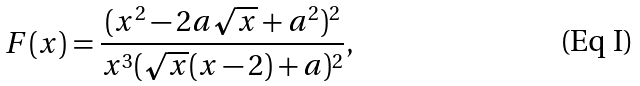<formula> <loc_0><loc_0><loc_500><loc_500>F ( x ) = \frac { ( x ^ { 2 } - 2 a \sqrt { x } + a ^ { 2 } ) ^ { 2 } } { x ^ { 3 } ( \sqrt { x } ( x - 2 ) + a ) ^ { 2 } } ,</formula> 